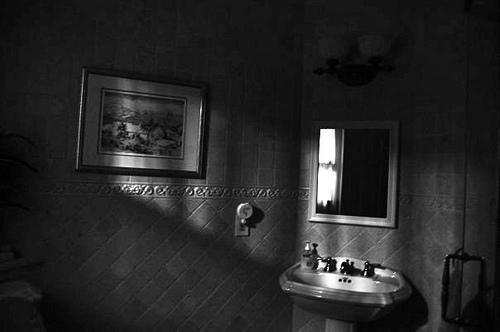How many sinks are in the bathroom?
Give a very brief answer. 1. How many people are on the boat?
Give a very brief answer. 0. 